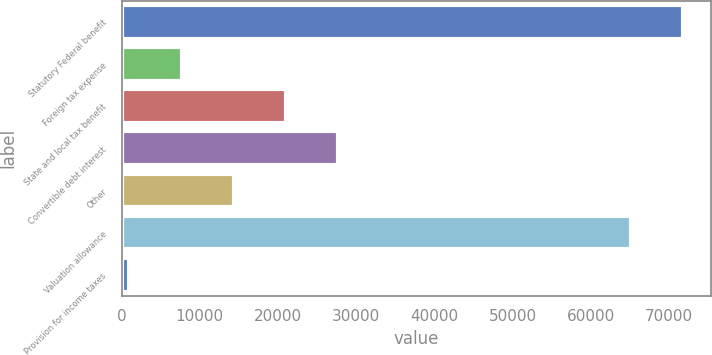Convert chart. <chart><loc_0><loc_0><loc_500><loc_500><bar_chart><fcel>Statutory Federal benefit<fcel>Foreign tax expense<fcel>State and local tax benefit<fcel>Convertible debt interest<fcel>Other<fcel>Valuation allowance<fcel>Provision for income taxes<nl><fcel>71766.1<fcel>7674.1<fcel>21012.3<fcel>27681.4<fcel>14343.2<fcel>65097<fcel>1005<nl></chart> 